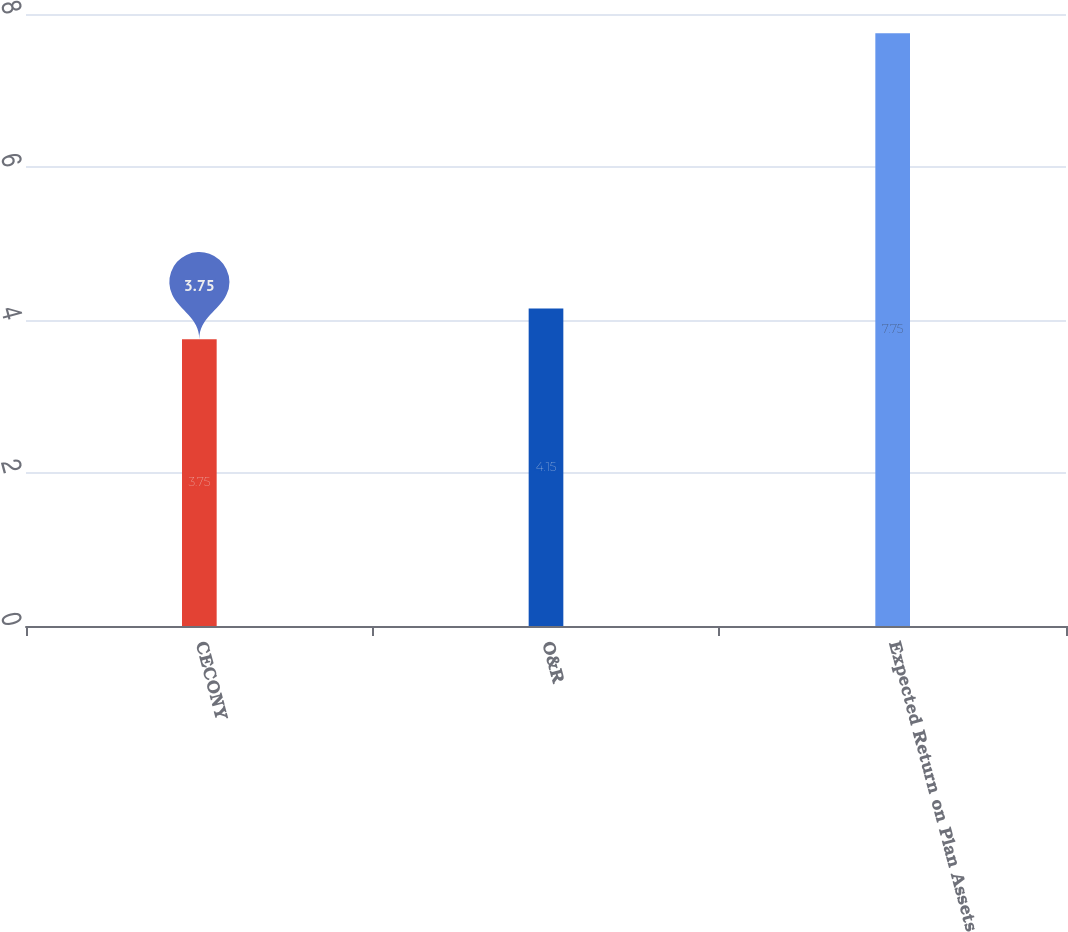Convert chart. <chart><loc_0><loc_0><loc_500><loc_500><bar_chart><fcel>CECONY<fcel>O&R<fcel>Expected Return on Plan Assets<nl><fcel>3.75<fcel>4.15<fcel>7.75<nl></chart> 